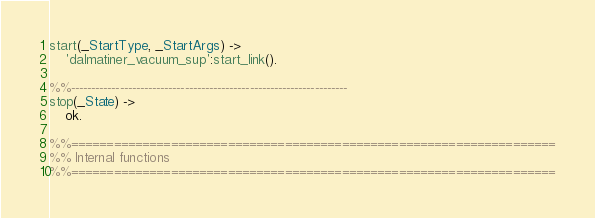Convert code to text. <code><loc_0><loc_0><loc_500><loc_500><_Erlang_>
start(_StartType, _StartArgs) ->
    'dalmatiner_vacuum_sup':start_link().

%%--------------------------------------------------------------------
stop(_State) ->
    ok.

%%====================================================================
%% Internal functions
%%====================================================================
</code> 